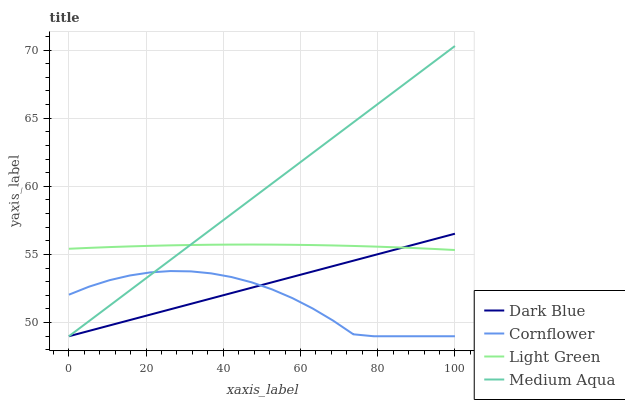Does Light Green have the minimum area under the curve?
Answer yes or no. No. Does Light Green have the maximum area under the curve?
Answer yes or no. No. Is Light Green the smoothest?
Answer yes or no. No. Is Light Green the roughest?
Answer yes or no. No. Does Light Green have the lowest value?
Answer yes or no. No. Does Light Green have the highest value?
Answer yes or no. No. Is Cornflower less than Light Green?
Answer yes or no. Yes. Is Light Green greater than Cornflower?
Answer yes or no. Yes. Does Cornflower intersect Light Green?
Answer yes or no. No. 